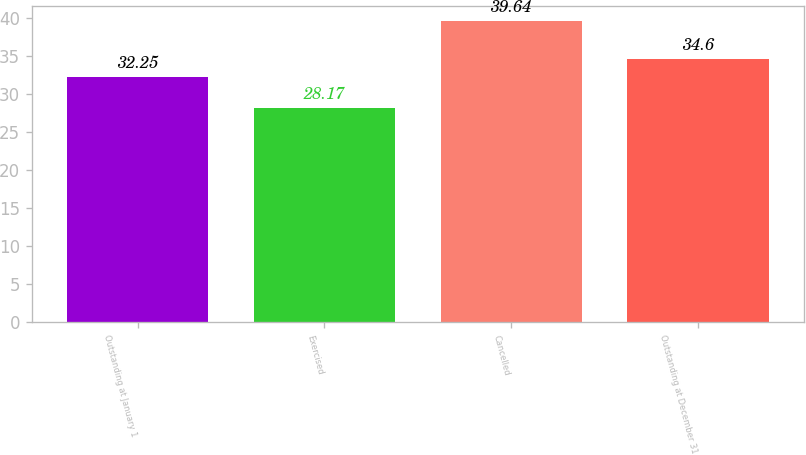<chart> <loc_0><loc_0><loc_500><loc_500><bar_chart><fcel>Outstanding at January 1<fcel>Exercised<fcel>Cancelled<fcel>Outstanding at December 31<nl><fcel>32.25<fcel>28.17<fcel>39.64<fcel>34.6<nl></chart> 